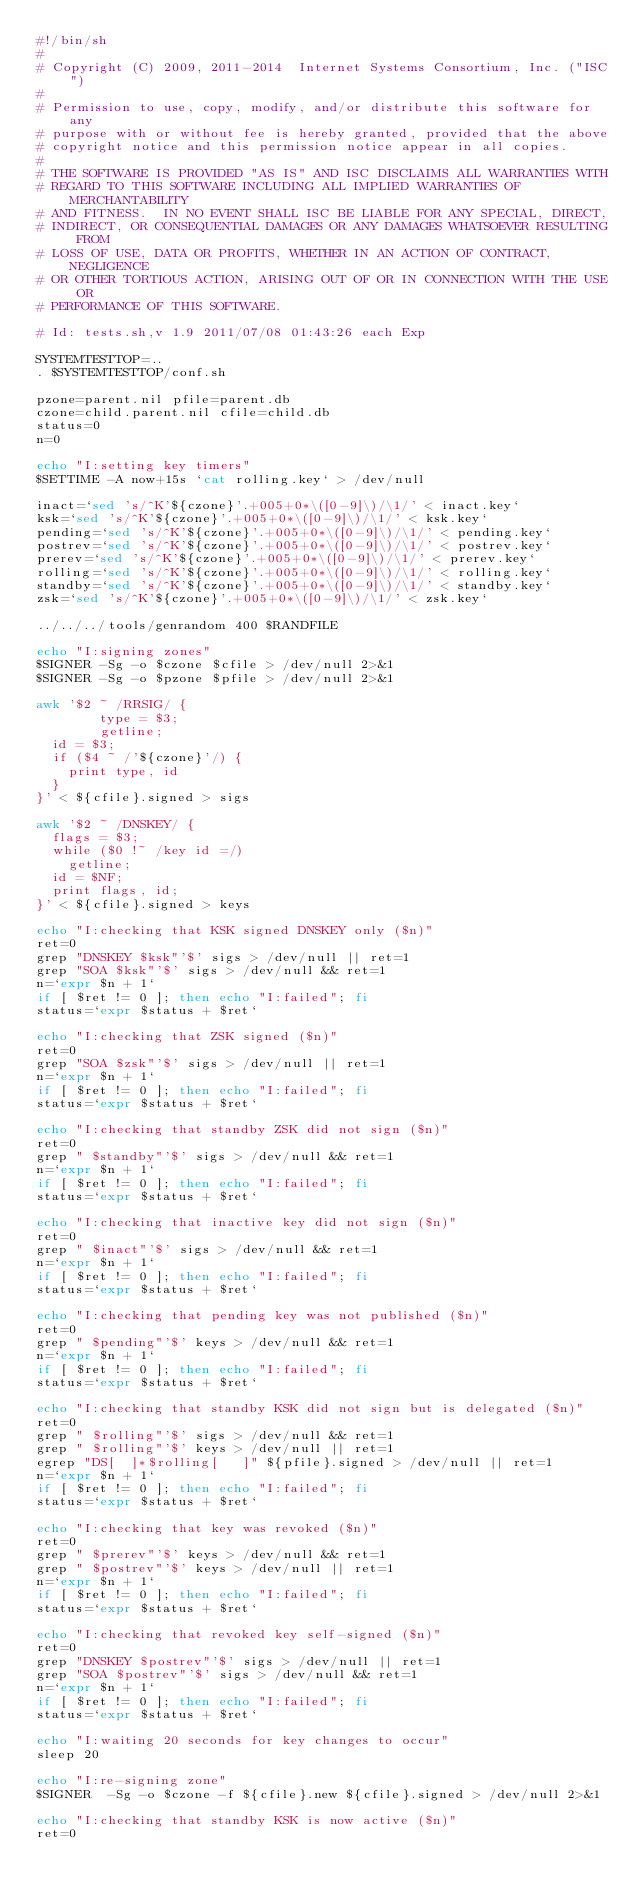Convert code to text. <code><loc_0><loc_0><loc_500><loc_500><_Bash_>#!/bin/sh
#
# Copyright (C) 2009, 2011-2014  Internet Systems Consortium, Inc. ("ISC")
#
# Permission to use, copy, modify, and/or distribute this software for any
# purpose with or without fee is hereby granted, provided that the above
# copyright notice and this permission notice appear in all copies.
#
# THE SOFTWARE IS PROVIDED "AS IS" AND ISC DISCLAIMS ALL WARRANTIES WITH
# REGARD TO THIS SOFTWARE INCLUDING ALL IMPLIED WARRANTIES OF MERCHANTABILITY
# AND FITNESS.  IN NO EVENT SHALL ISC BE LIABLE FOR ANY SPECIAL, DIRECT,
# INDIRECT, OR CONSEQUENTIAL DAMAGES OR ANY DAMAGES WHATSOEVER RESULTING FROM
# LOSS OF USE, DATA OR PROFITS, WHETHER IN AN ACTION OF CONTRACT, NEGLIGENCE
# OR OTHER TORTIOUS ACTION, ARISING OUT OF OR IN CONNECTION WITH THE USE OR
# PERFORMANCE OF THIS SOFTWARE.

# Id: tests.sh,v 1.9 2011/07/08 01:43:26 each Exp 

SYSTEMTESTTOP=..
. $SYSTEMTESTTOP/conf.sh

pzone=parent.nil pfile=parent.db
czone=child.parent.nil cfile=child.db
status=0
n=0

echo "I:setting key timers"
$SETTIME -A now+15s `cat rolling.key` > /dev/null

inact=`sed 's/^K'${czone}'.+005+0*\([0-9]\)/\1/' < inact.key`
ksk=`sed 's/^K'${czone}'.+005+0*\([0-9]\)/\1/' < ksk.key`
pending=`sed 's/^K'${czone}'.+005+0*\([0-9]\)/\1/' < pending.key`
postrev=`sed 's/^K'${czone}'.+005+0*\([0-9]\)/\1/' < postrev.key`
prerev=`sed 's/^K'${czone}'.+005+0*\([0-9]\)/\1/' < prerev.key`
rolling=`sed 's/^K'${czone}'.+005+0*\([0-9]\)/\1/' < rolling.key`
standby=`sed 's/^K'${czone}'.+005+0*\([0-9]\)/\1/' < standby.key`
zsk=`sed 's/^K'${czone}'.+005+0*\([0-9]\)/\1/' < zsk.key`

../../../tools/genrandom 400 $RANDFILE

echo "I:signing zones"
$SIGNER -Sg -o $czone $cfile > /dev/null 2>&1
$SIGNER -Sg -o $pzone $pfile > /dev/null 2>&1

awk '$2 ~ /RRSIG/ {
        type = $3;
        getline;
	id = $3;
	if ($4 ~ /'${czone}'/) {
		print type, id
	}
}' < ${cfile}.signed > sigs

awk '$2 ~ /DNSKEY/ {
	flags = $3;
	while ($0 !~ /key id =/)
		getline;
	id = $NF;
	print flags, id;
}' < ${cfile}.signed > keys

echo "I:checking that KSK signed DNSKEY only ($n)"
ret=0
grep "DNSKEY $ksk"'$' sigs > /dev/null || ret=1
grep "SOA $ksk"'$' sigs > /dev/null && ret=1
n=`expr $n + 1`
if [ $ret != 0 ]; then echo "I:failed"; fi
status=`expr $status + $ret`

echo "I:checking that ZSK signed ($n)"
ret=0
grep "SOA $zsk"'$' sigs > /dev/null || ret=1
n=`expr $n + 1`
if [ $ret != 0 ]; then echo "I:failed"; fi
status=`expr $status + $ret`

echo "I:checking that standby ZSK did not sign ($n)"
ret=0
grep " $standby"'$' sigs > /dev/null && ret=1
n=`expr $n + 1`
if [ $ret != 0 ]; then echo "I:failed"; fi
status=`expr $status + $ret`

echo "I:checking that inactive key did not sign ($n)"
ret=0
grep " $inact"'$' sigs > /dev/null && ret=1
n=`expr $n + 1`
if [ $ret != 0 ]; then echo "I:failed"; fi
status=`expr $status + $ret`

echo "I:checking that pending key was not published ($n)"
ret=0
grep " $pending"'$' keys > /dev/null && ret=1
n=`expr $n + 1`
if [ $ret != 0 ]; then echo "I:failed"; fi
status=`expr $status + $ret`

echo "I:checking that standby KSK did not sign but is delegated ($n)"
ret=0
grep " $rolling"'$' sigs > /dev/null && ret=1
grep " $rolling"'$' keys > /dev/null || ret=1
egrep "DS[ 	]*$rolling[ 	]" ${pfile}.signed > /dev/null || ret=1
n=`expr $n + 1`
if [ $ret != 0 ]; then echo "I:failed"; fi
status=`expr $status + $ret`

echo "I:checking that key was revoked ($n)"
ret=0
grep " $prerev"'$' keys > /dev/null && ret=1
grep " $postrev"'$' keys > /dev/null || ret=1
n=`expr $n + 1`
if [ $ret != 0 ]; then echo "I:failed"; fi
status=`expr $status + $ret`

echo "I:checking that revoked key self-signed ($n)"
ret=0
grep "DNSKEY $postrev"'$' sigs > /dev/null || ret=1
grep "SOA $postrev"'$' sigs > /dev/null && ret=1
n=`expr $n + 1`
if [ $ret != 0 ]; then echo "I:failed"; fi
status=`expr $status + $ret`

echo "I:waiting 20 seconds for key changes to occur"
sleep 20

echo "I:re-signing zone"
$SIGNER  -Sg -o $czone -f ${cfile}.new ${cfile}.signed > /dev/null 2>&1

echo "I:checking that standby KSK is now active ($n)"
ret=0</code> 